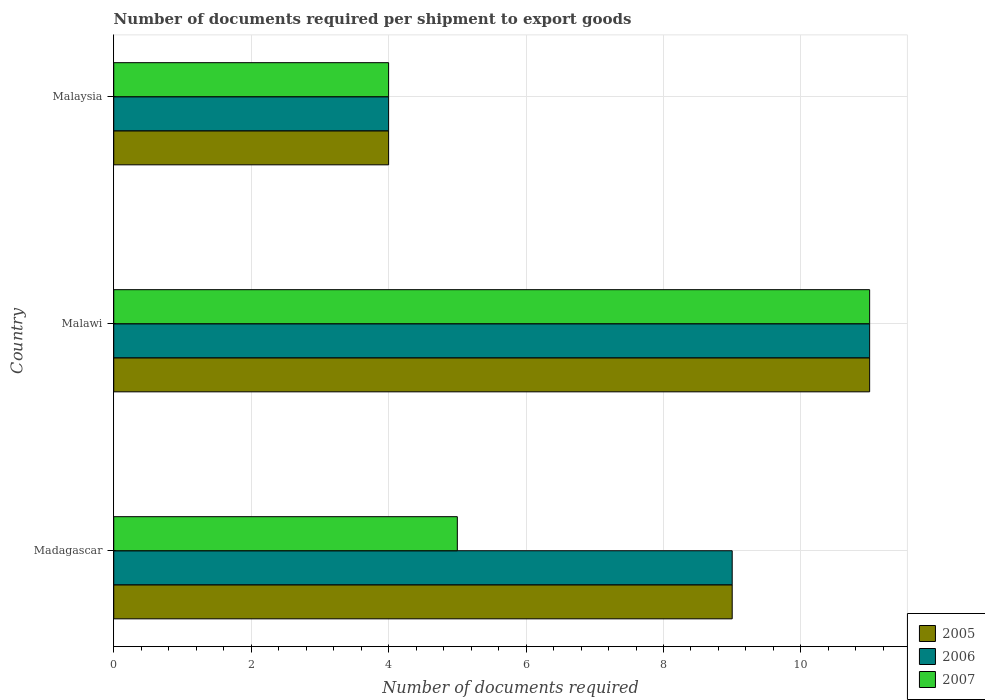How many different coloured bars are there?
Your response must be concise. 3. How many groups of bars are there?
Provide a short and direct response. 3. Are the number of bars per tick equal to the number of legend labels?
Your response must be concise. Yes. How many bars are there on the 1st tick from the top?
Your answer should be very brief. 3. How many bars are there on the 3rd tick from the bottom?
Your answer should be compact. 3. What is the label of the 1st group of bars from the top?
Provide a succinct answer. Malaysia. In which country was the number of documents required per shipment to export goods in 2005 maximum?
Offer a terse response. Malawi. In which country was the number of documents required per shipment to export goods in 2006 minimum?
Provide a succinct answer. Malaysia. What is the total number of documents required per shipment to export goods in 2006 in the graph?
Ensure brevity in your answer.  24. What is the difference between the number of documents required per shipment to export goods in 2006 in Madagascar and that in Malaysia?
Offer a terse response. 5. What is the difference between the number of documents required per shipment to export goods in 2007 in Malaysia and the number of documents required per shipment to export goods in 2006 in Madagascar?
Make the answer very short. -5. What is the average number of documents required per shipment to export goods in 2006 per country?
Keep it short and to the point. 8. In how many countries, is the number of documents required per shipment to export goods in 2006 greater than 4 ?
Your answer should be compact. 2. What is the ratio of the number of documents required per shipment to export goods in 2007 in Malawi to that in Malaysia?
Offer a very short reply. 2.75. Is the number of documents required per shipment to export goods in 2005 in Malawi less than that in Malaysia?
Make the answer very short. No. Is the difference between the number of documents required per shipment to export goods in 2007 in Madagascar and Malawi greater than the difference between the number of documents required per shipment to export goods in 2006 in Madagascar and Malawi?
Give a very brief answer. No. What is the difference between the highest and the second highest number of documents required per shipment to export goods in 2006?
Make the answer very short. 2. What is the difference between the highest and the lowest number of documents required per shipment to export goods in 2005?
Your answer should be compact. 7. In how many countries, is the number of documents required per shipment to export goods in 2006 greater than the average number of documents required per shipment to export goods in 2006 taken over all countries?
Your answer should be compact. 2. Is the sum of the number of documents required per shipment to export goods in 2005 in Madagascar and Malaysia greater than the maximum number of documents required per shipment to export goods in 2007 across all countries?
Offer a terse response. Yes. What does the 1st bar from the top in Malawi represents?
Keep it short and to the point. 2007. What does the 1st bar from the bottom in Madagascar represents?
Your response must be concise. 2005. Is it the case that in every country, the sum of the number of documents required per shipment to export goods in 2006 and number of documents required per shipment to export goods in 2005 is greater than the number of documents required per shipment to export goods in 2007?
Your answer should be compact. Yes. Are the values on the major ticks of X-axis written in scientific E-notation?
Your answer should be compact. No. Does the graph contain grids?
Give a very brief answer. Yes. Where does the legend appear in the graph?
Offer a very short reply. Bottom right. How are the legend labels stacked?
Offer a terse response. Vertical. What is the title of the graph?
Offer a very short reply. Number of documents required per shipment to export goods. Does "2005" appear as one of the legend labels in the graph?
Provide a succinct answer. Yes. What is the label or title of the X-axis?
Provide a short and direct response. Number of documents required. What is the Number of documents required of 2006 in Madagascar?
Provide a short and direct response. 9. What is the Number of documents required of 2007 in Madagascar?
Ensure brevity in your answer.  5. What is the Number of documents required in 2005 in Malawi?
Provide a short and direct response. 11. What is the Number of documents required of 2006 in Malaysia?
Provide a succinct answer. 4. What is the Number of documents required of 2007 in Malaysia?
Give a very brief answer. 4. Across all countries, what is the maximum Number of documents required in 2005?
Ensure brevity in your answer.  11. Across all countries, what is the minimum Number of documents required of 2007?
Offer a terse response. 4. What is the total Number of documents required in 2005 in the graph?
Provide a short and direct response. 24. What is the total Number of documents required in 2006 in the graph?
Your answer should be very brief. 24. What is the difference between the Number of documents required in 2005 in Madagascar and that in Malawi?
Your answer should be compact. -2. What is the difference between the Number of documents required in 2006 in Madagascar and that in Malaysia?
Keep it short and to the point. 5. What is the difference between the Number of documents required in 2005 in Malawi and that in Malaysia?
Your answer should be compact. 7. What is the difference between the Number of documents required in 2006 in Malawi and that in Malaysia?
Keep it short and to the point. 7. What is the difference between the Number of documents required in 2006 in Madagascar and the Number of documents required in 2007 in Malawi?
Offer a terse response. -2. What is the difference between the Number of documents required in 2005 in Madagascar and the Number of documents required in 2006 in Malaysia?
Your answer should be compact. 5. What is the average Number of documents required of 2005 per country?
Give a very brief answer. 8. What is the average Number of documents required of 2006 per country?
Provide a short and direct response. 8. What is the difference between the Number of documents required in 2005 and Number of documents required in 2006 in Madagascar?
Your answer should be compact. 0. What is the difference between the Number of documents required of 2006 and Number of documents required of 2007 in Madagascar?
Your answer should be very brief. 4. What is the difference between the Number of documents required in 2005 and Number of documents required in 2007 in Malawi?
Provide a short and direct response. 0. What is the difference between the Number of documents required of 2005 and Number of documents required of 2006 in Malaysia?
Provide a succinct answer. 0. What is the difference between the Number of documents required of 2006 and Number of documents required of 2007 in Malaysia?
Ensure brevity in your answer.  0. What is the ratio of the Number of documents required of 2005 in Madagascar to that in Malawi?
Make the answer very short. 0.82. What is the ratio of the Number of documents required in 2006 in Madagascar to that in Malawi?
Provide a succinct answer. 0.82. What is the ratio of the Number of documents required in 2007 in Madagascar to that in Malawi?
Your answer should be compact. 0.45. What is the ratio of the Number of documents required of 2005 in Madagascar to that in Malaysia?
Offer a very short reply. 2.25. What is the ratio of the Number of documents required of 2006 in Madagascar to that in Malaysia?
Give a very brief answer. 2.25. What is the ratio of the Number of documents required in 2005 in Malawi to that in Malaysia?
Your answer should be compact. 2.75. What is the ratio of the Number of documents required in 2006 in Malawi to that in Malaysia?
Your answer should be compact. 2.75. What is the ratio of the Number of documents required of 2007 in Malawi to that in Malaysia?
Provide a succinct answer. 2.75. What is the difference between the highest and the second highest Number of documents required in 2005?
Ensure brevity in your answer.  2. What is the difference between the highest and the lowest Number of documents required of 2005?
Provide a succinct answer. 7. What is the difference between the highest and the lowest Number of documents required in 2007?
Your answer should be compact. 7. 